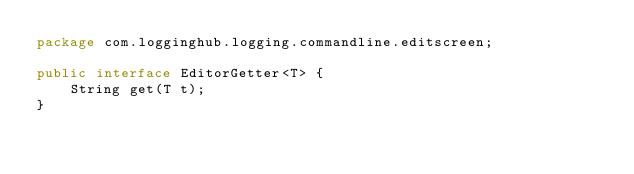<code> <loc_0><loc_0><loc_500><loc_500><_Java_>package com.logginghub.logging.commandline.editscreen;

public interface EditorGetter<T> {
    String get(T t);
}
</code> 